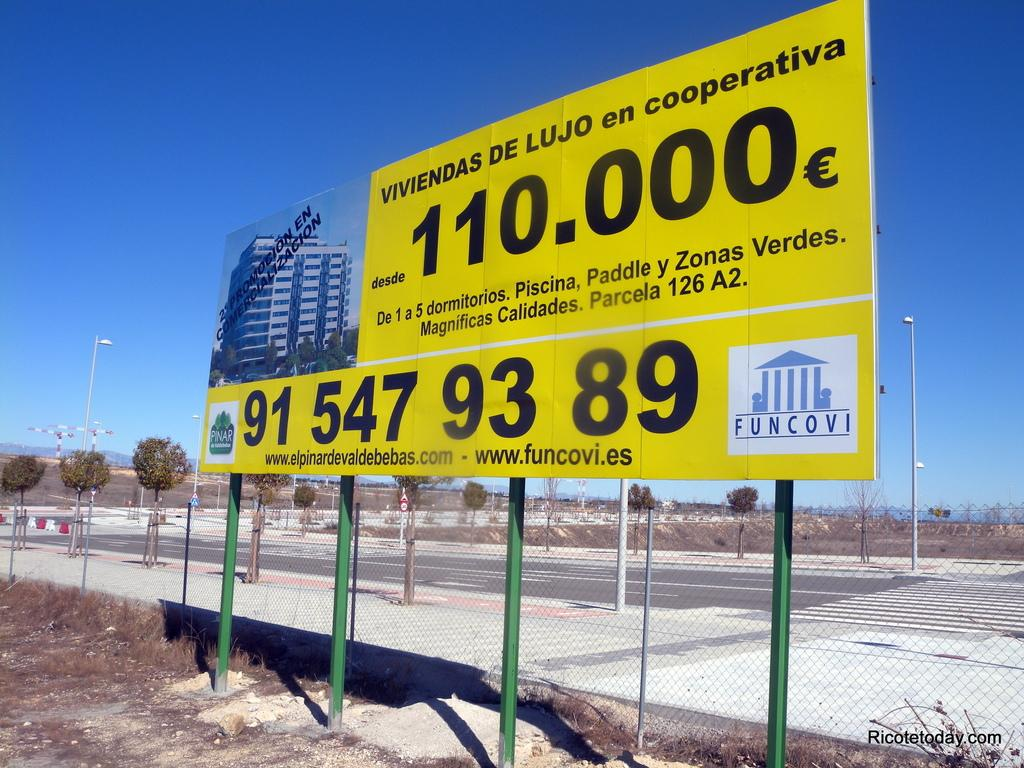<image>
Write a terse but informative summary of the picture. a sign that has the number 89 at the corner of it 